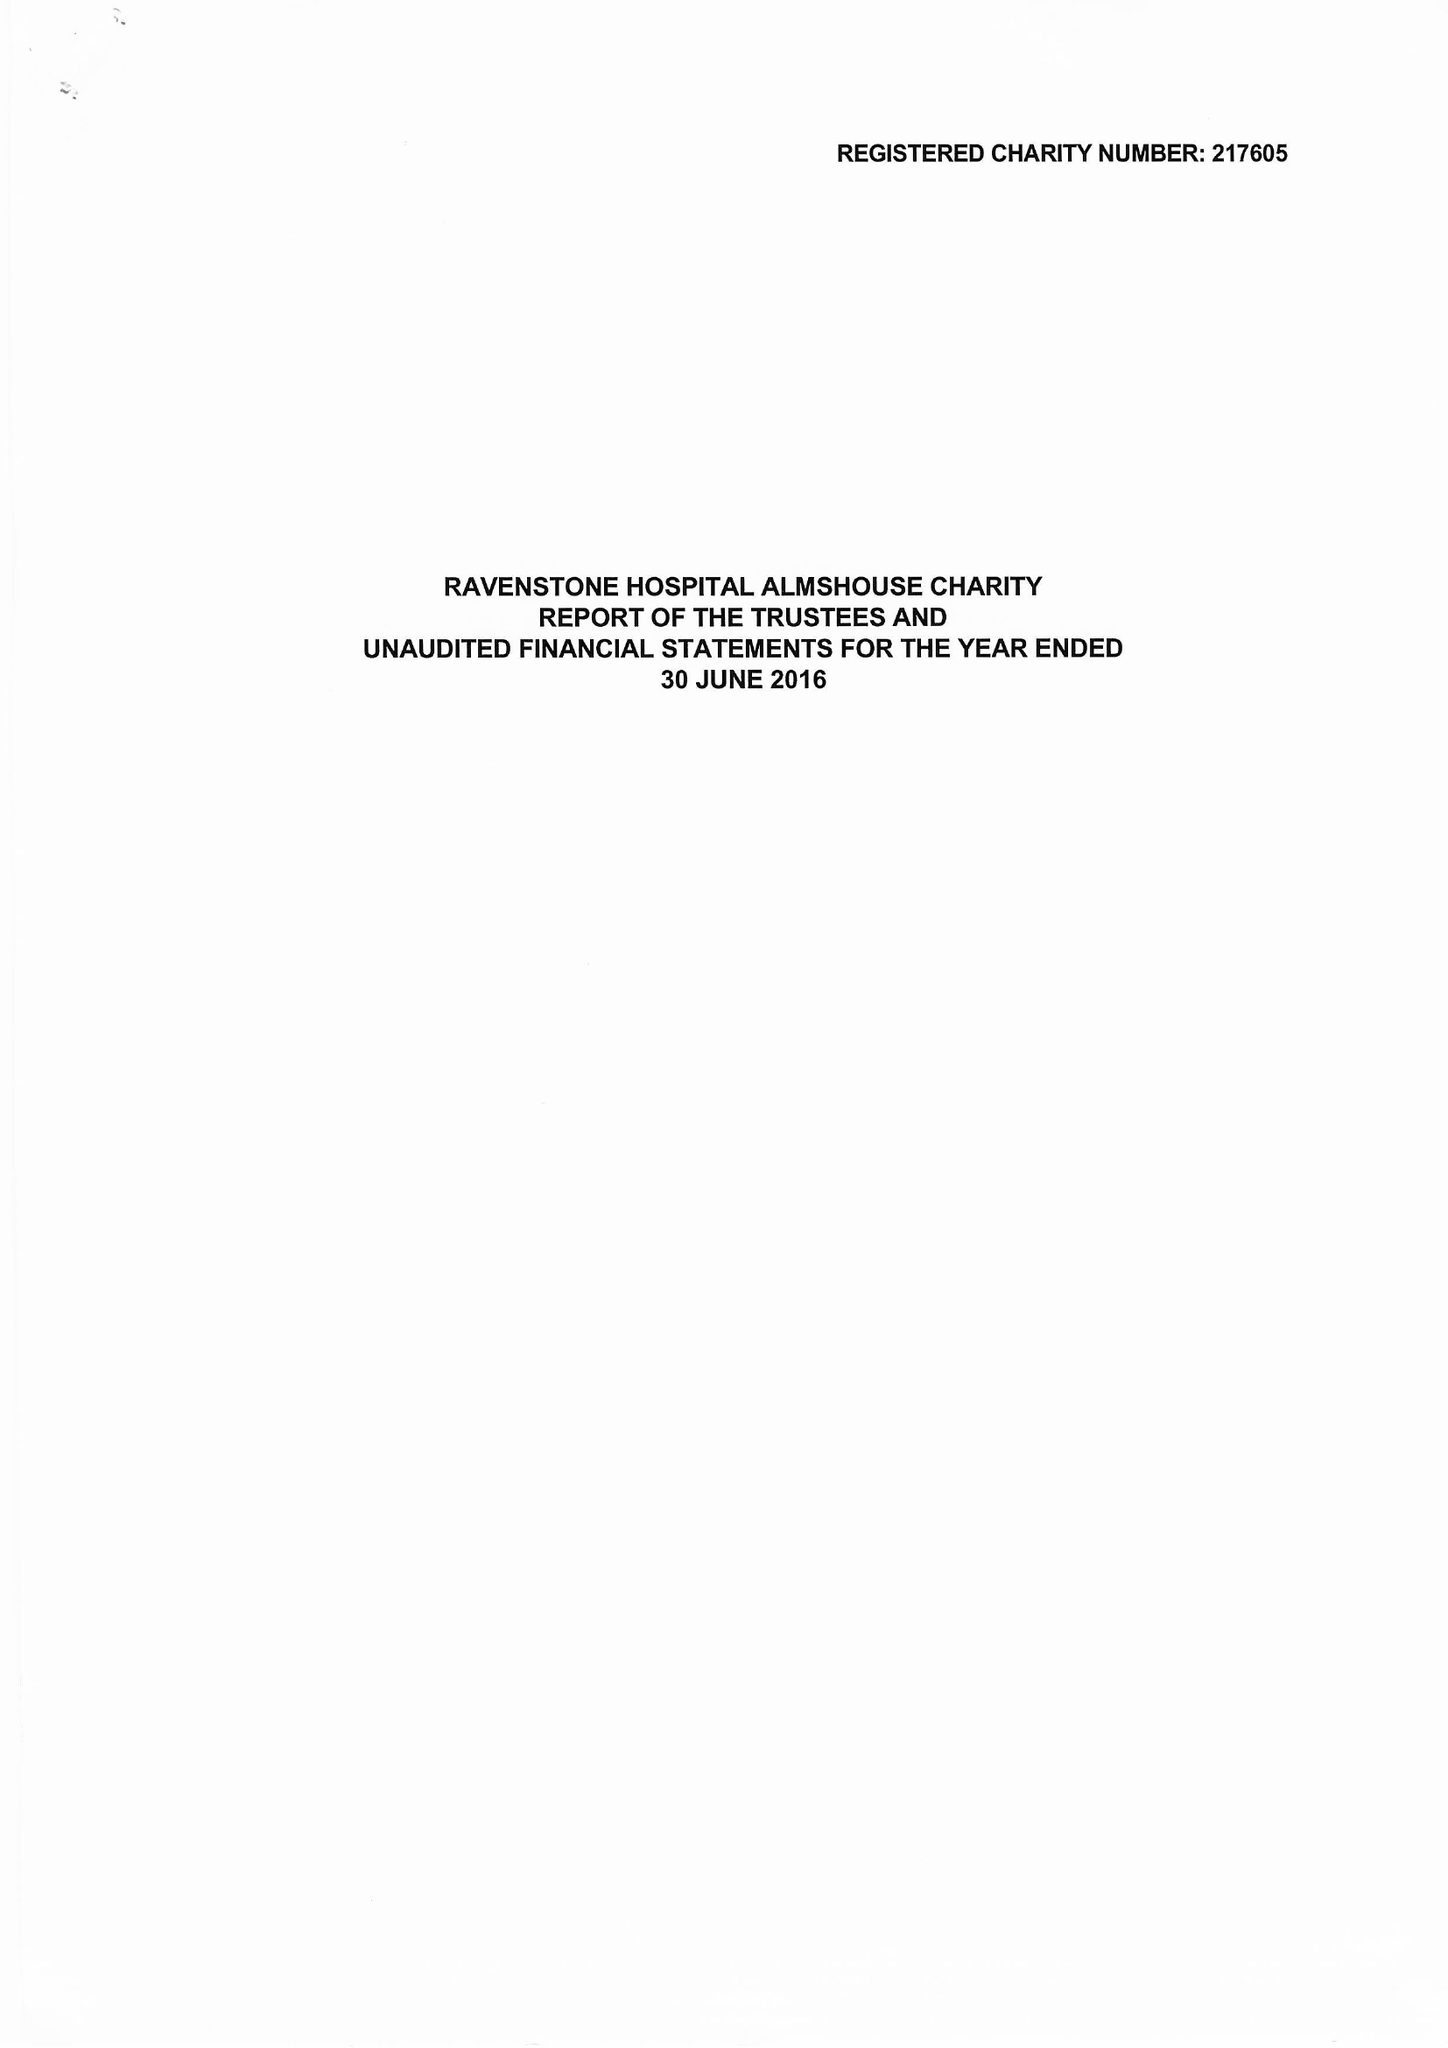What is the value for the address__postcode?
Answer the question using a single word or phrase. DE65 6GD 